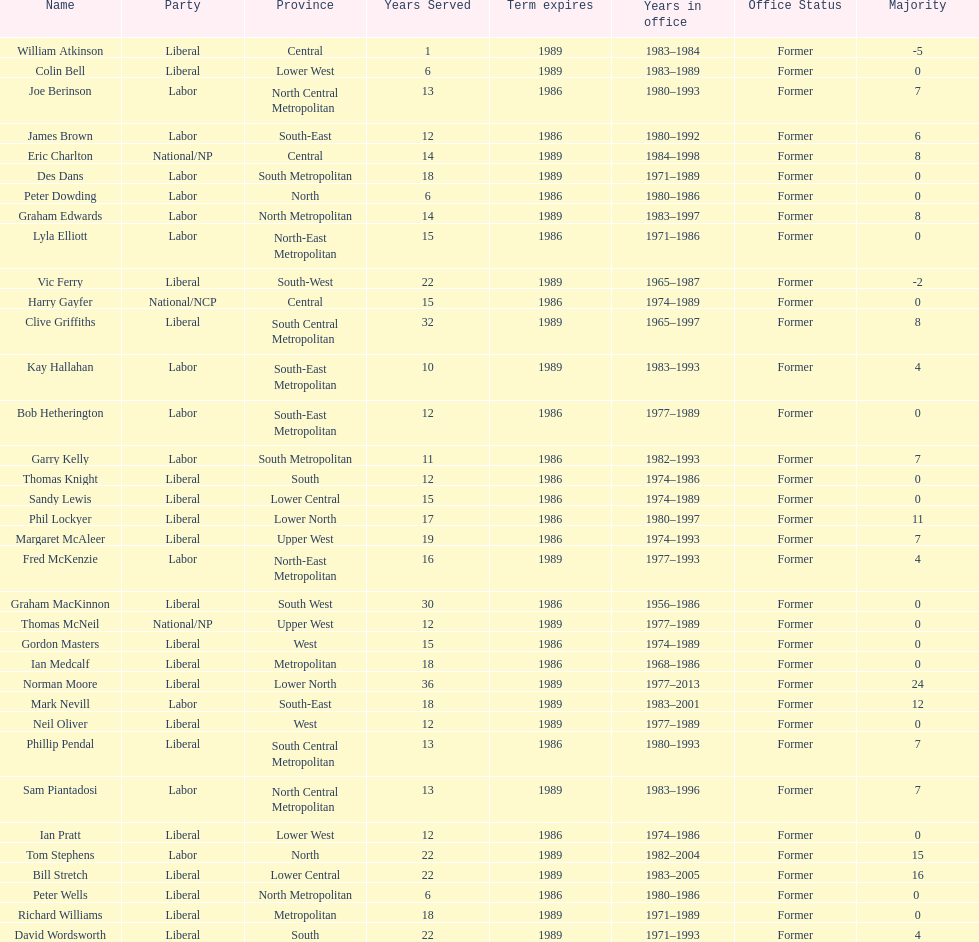What is the total number of members whose term expires in 1989? 9. 